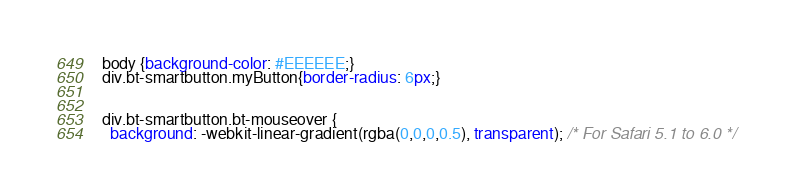<code> <loc_0><loc_0><loc_500><loc_500><_CSS_>body {background-color: #EEEEEE;}
div.bt-smartbutton.myButton{border-radius: 6px;}


div.bt-smartbutton.bt-mouseover {
  background: -webkit-linear-gradient(rgba(0,0,0,0.5), transparent); /* For Safari 5.1 to 6.0 */</code> 